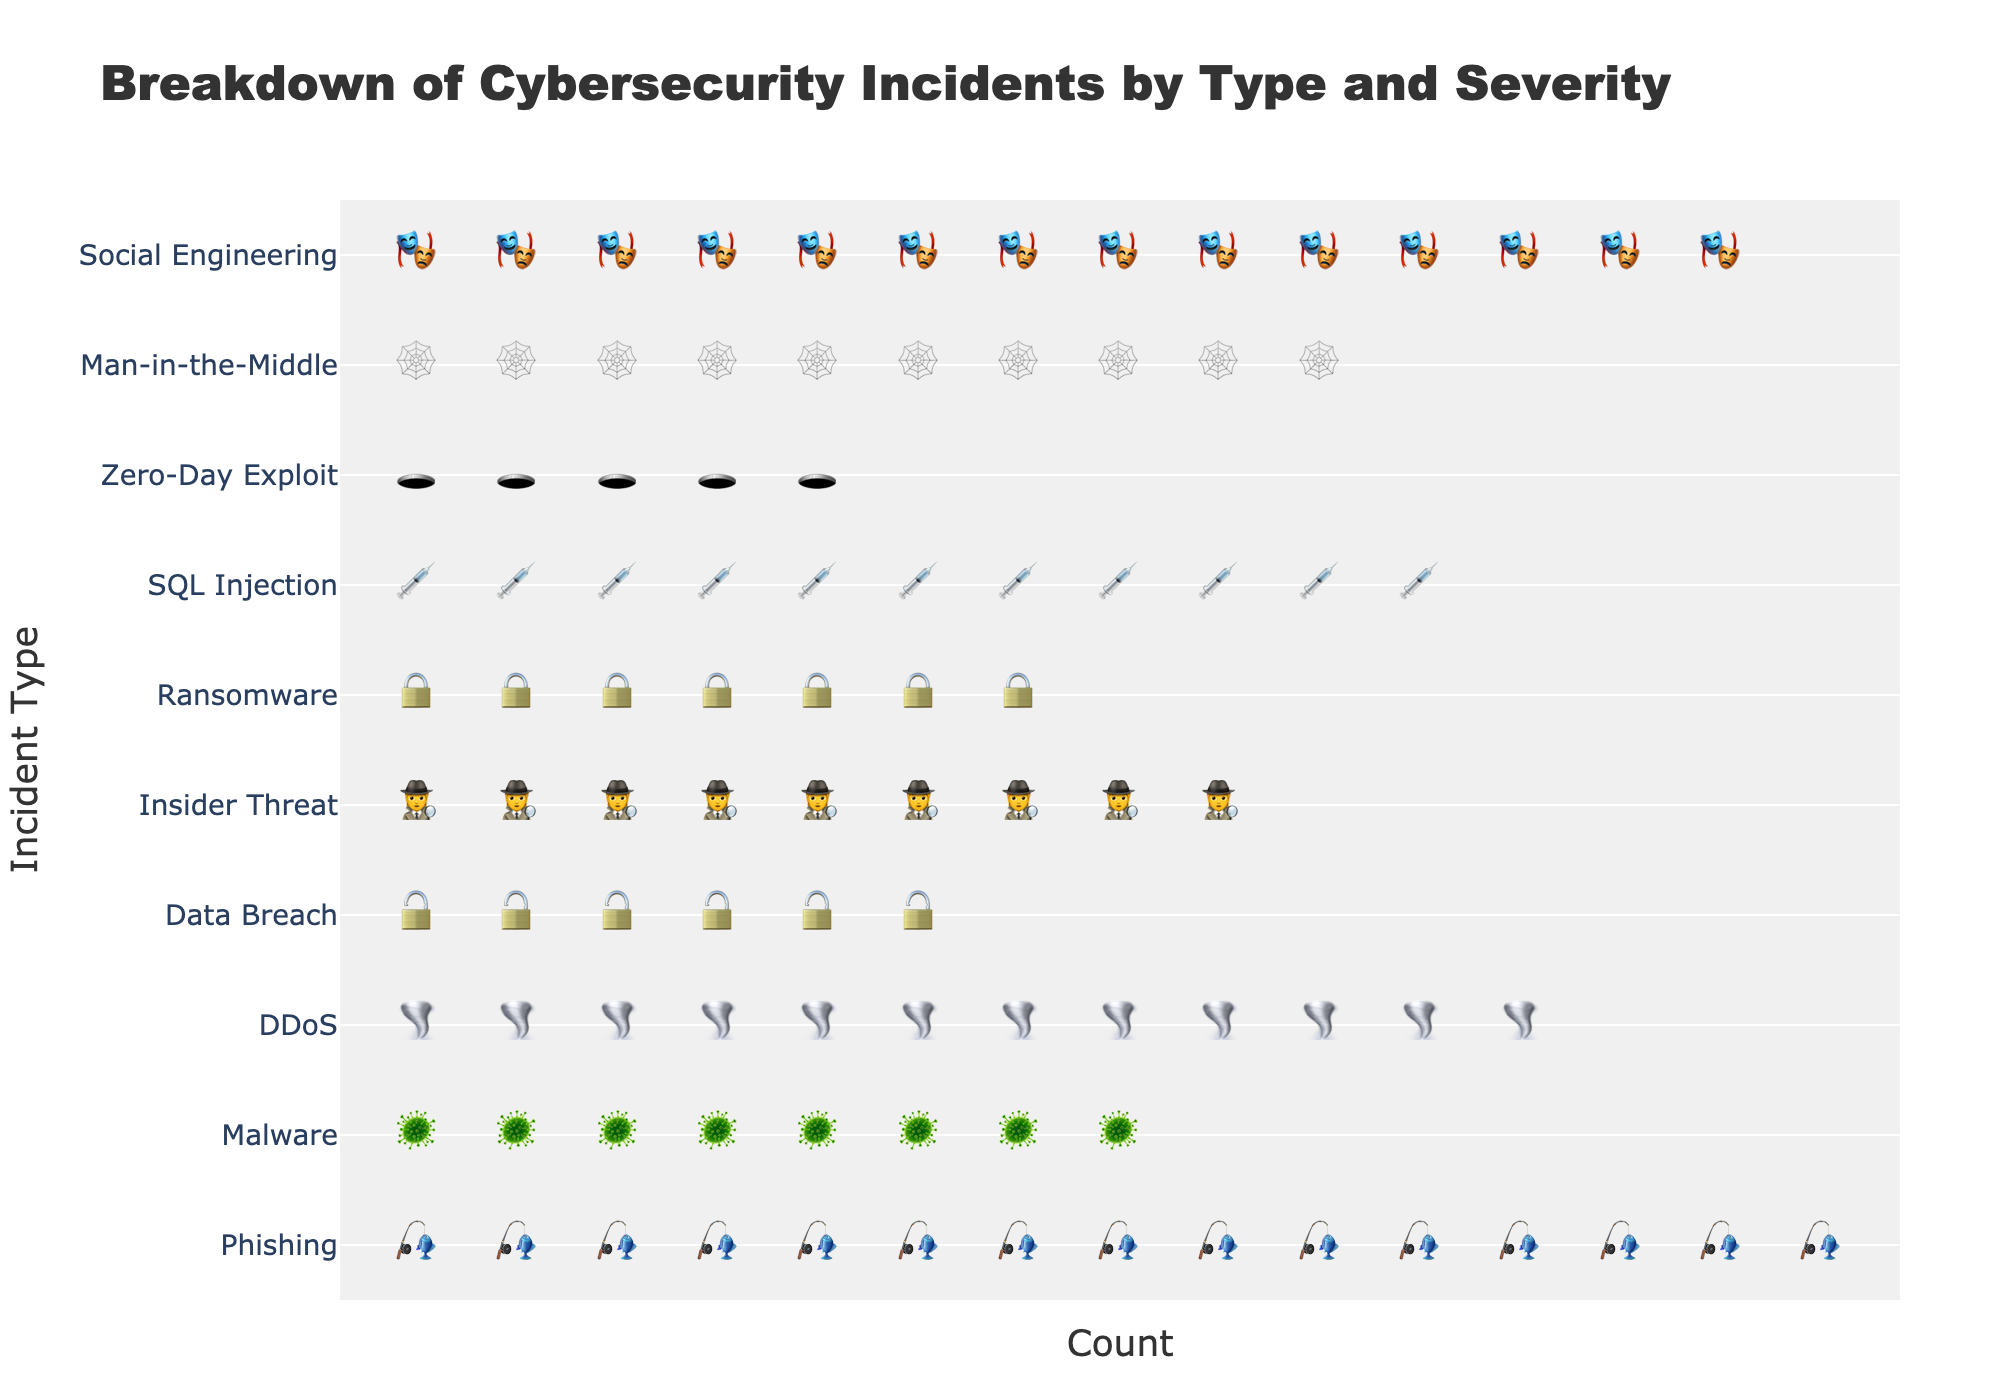What is the title of the figure? The title of the figure is shown at the top and it represents the main topic of the plot. The title is 'Breakdown of Cybersecurity Incidents by Type and Severity'
Answer: Breakdown of Cybersecurity Incidents by Type and Severity Which type of incident has the highest count? By examining the length and number of icons for each type of incident, 'Phishing' has the longest row of icons, indicating it has the highest count with 15 incidents
Answer: Phishing How many 'Critical' severity incidents are there in total? Add up all the counts for incidents classified as 'Critical': Malware (8), Data Breach (6), Ransomware (7), and Zero-Day Exploit (5). 8 + 6 + 7 + 5 = 26
Answer: 26 Which incident types fall under the 'High' severity category? Look for types with icons in the orange color which denotes 'High' severity: Phishing, Insider Threat, and Man-in-the-Middle
Answer: Phishing, Insider Threat, Man-in-the-Middle What is the average number of incidents for 'Medium' severity types? Sum the counts of 'Medium' severity types (DDoS 12, SQL Injection 11, Social Engineering 14) and divide by the number of these types. (12 + 11 + 14) / 3 = 37 / 3 ≈ 12.33
Answer: ~12.33 Compare the count of 'Ransomware' incidents to 'Insider Threat' incidents. Which is higher? 'Ransomware' has a count of 7 incidents and 'Insider Threat' has a count of 9 incidents. Therefore, 'Insider Threat' is higher
Answer: Insider Threat How many incidents are there for the SQL Injection type? Locate the 'SQL Injection' row and count the icons present. There are 11
Answer: 11 Which has more incidents: Malware or Data Breach? Compare the counts of incidents for 'Malware' and 'Data Breach'. Malware (8) has more incidents than Data Breach (6)
Answer: Malware What color represents 'Medium' severity incidents? Look at the legend and the color used for icons in 'Medium' severity incidents. It is yellow
Answer: Yellow Identify the types of incidents that have counts less than 10. Identify each incident with a count less than 10: Malware (8), Data Breach (6), Ransomware (7), Zero-Day Exploit (5)
Answer: Malware, Data Breach, Ransomware, Zero-Day Exploit 